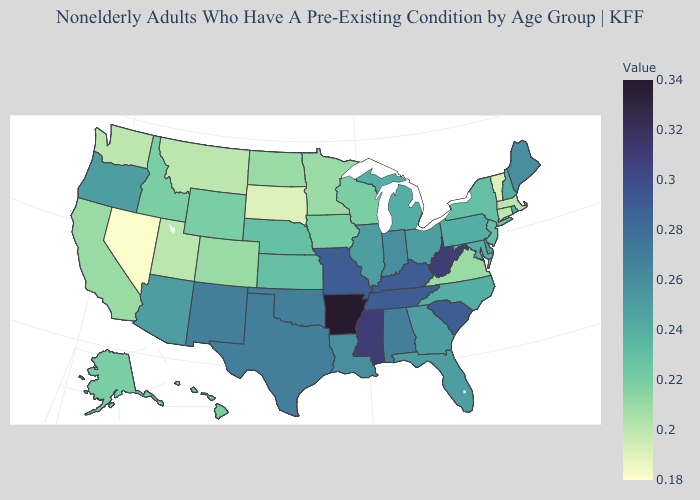Which states have the lowest value in the USA?
Concise answer only. Nevada. Which states have the highest value in the USA?
Write a very short answer. Arkansas. Does Rhode Island have the lowest value in the Northeast?
Concise answer only. No. Does Arizona have a higher value than South Dakota?
Keep it brief. Yes. Does Illinois have the lowest value in the USA?
Concise answer only. No. 